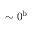<formula> <loc_0><loc_0><loc_500><loc_500>\sim 0 ^ { b }</formula> 